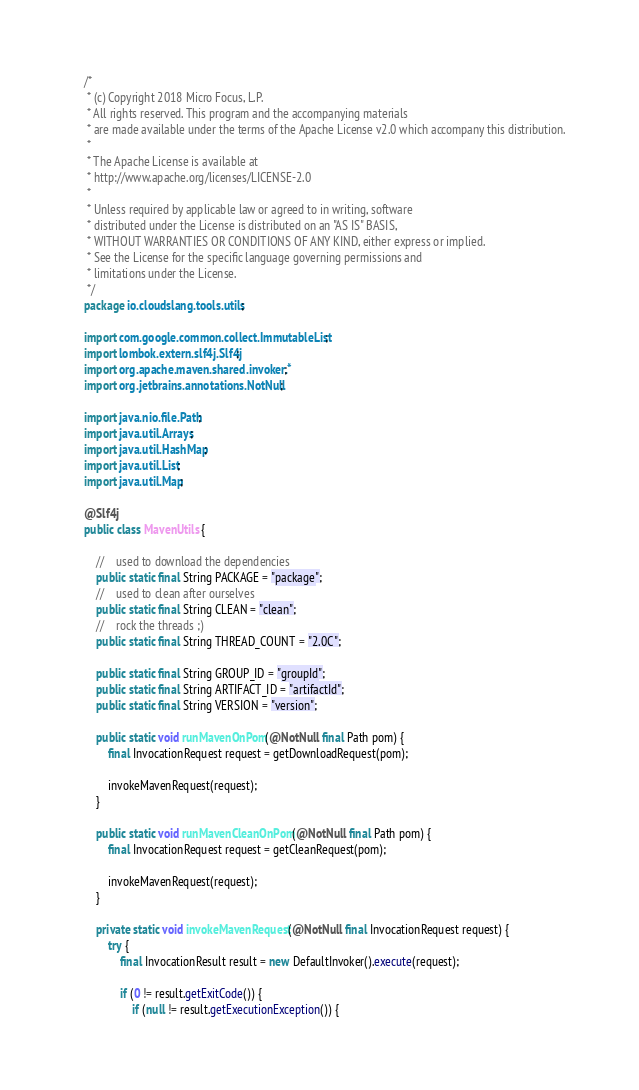<code> <loc_0><loc_0><loc_500><loc_500><_Java_>/*
 * (c) Copyright 2018 Micro Focus, L.P.
 * All rights reserved. This program and the accompanying materials
 * are made available under the terms of the Apache License v2.0 which accompany this distribution.
 *
 * The Apache License is available at
 * http://www.apache.org/licenses/LICENSE-2.0
 *
 * Unless required by applicable law or agreed to in writing, software
 * distributed under the License is distributed on an "AS IS" BASIS,
 * WITHOUT WARRANTIES OR CONDITIONS OF ANY KIND, either express or implied.
 * See the License for the specific language governing permissions and
 * limitations under the License.
 */
package io.cloudslang.tools.utils;

import com.google.common.collect.ImmutableList;
import lombok.extern.slf4j.Slf4j;
import org.apache.maven.shared.invoker.*;
import org.jetbrains.annotations.NotNull;

import java.nio.file.Path;
import java.util.Arrays;
import java.util.HashMap;
import java.util.List;
import java.util.Map;

@Slf4j
public class MavenUtils {

    //    used to download the dependencies
    public static final String PACKAGE = "package";
    //    used to clean after ourselves
    public static final String CLEAN = "clean";
    //    rock the threads ;)
    public static final String THREAD_COUNT = "2.0C";

    public static final String GROUP_ID = "groupId";
    public static final String ARTIFACT_ID = "artifactId";
    public static final String VERSION = "version";

    public static void runMavenOnPom(@NotNull final Path pom) {
        final InvocationRequest request = getDownloadRequest(pom);

        invokeMavenRequest(request);
    }

    public static void runMavenCleanOnPom(@NotNull final Path pom) {
        final InvocationRequest request = getCleanRequest(pom);

        invokeMavenRequest(request);
    }

    private static void invokeMavenRequest(@NotNull final InvocationRequest request) {
        try {
            final InvocationResult result = new DefaultInvoker().execute(request);

            if (0 != result.getExitCode()) {
                if (null != result.getExecutionException()) {</code> 